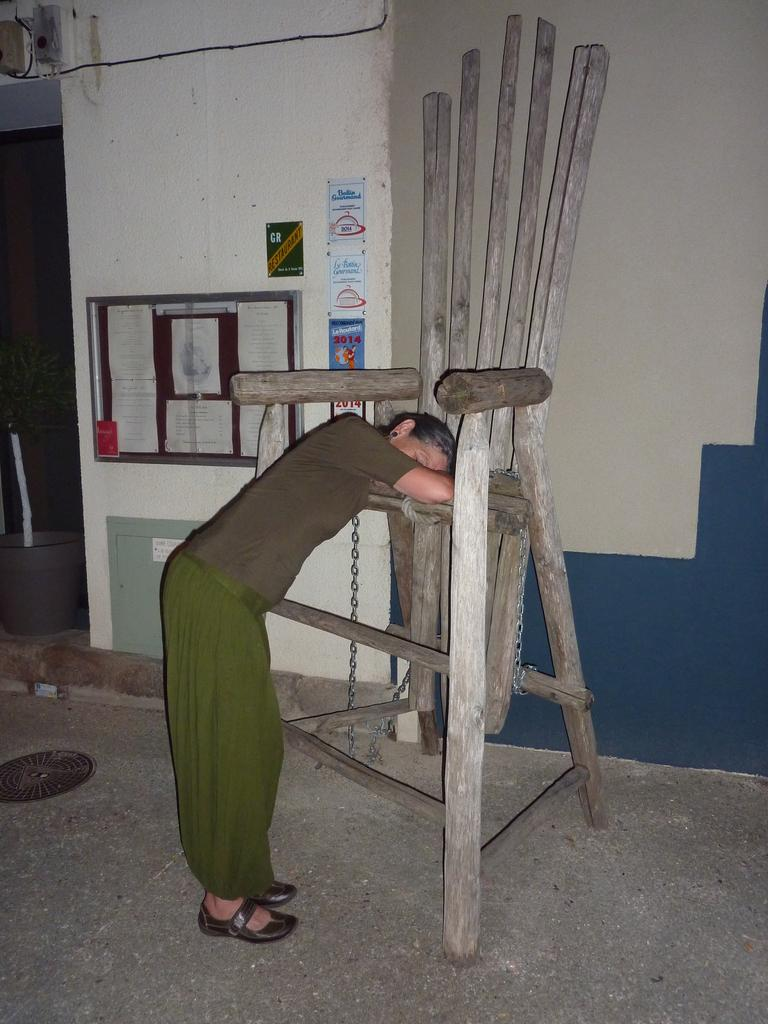What is present in the image along with the person? There is a house plant, a notice board, posters, a wooden chair, chains, a wall, and a cable in the image. Can you describe the notice board in the image? The notice board is a board where notices or announcements can be displayed. What type of furniture is present in the image? There is a wooden chair in the image. What is attached to the wall in the image? There is a cable attached to the wall in the image. What type of crime is being committed in the image? There is no indication of any crime being committed in the image. How does the person in the image plan to cause trouble? There is no indication of any trouble being caused in the image. 